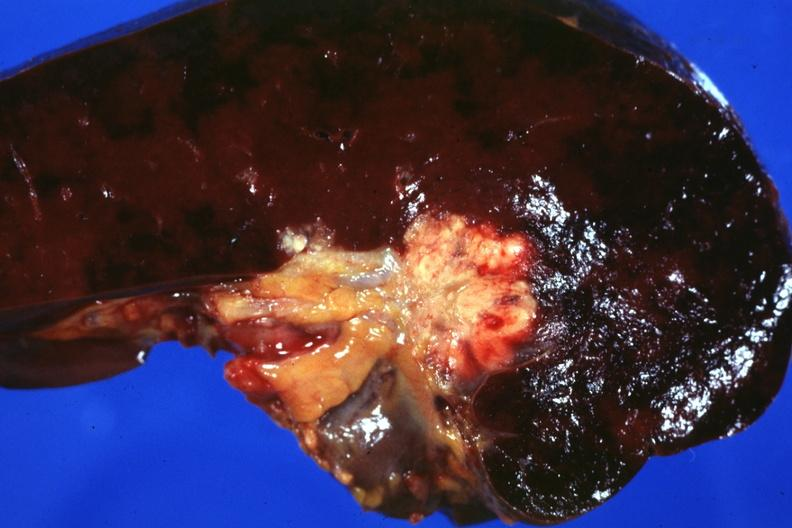s node metastases spread into the spleen in this case?
Answer the question using a single word or phrase. Yes 